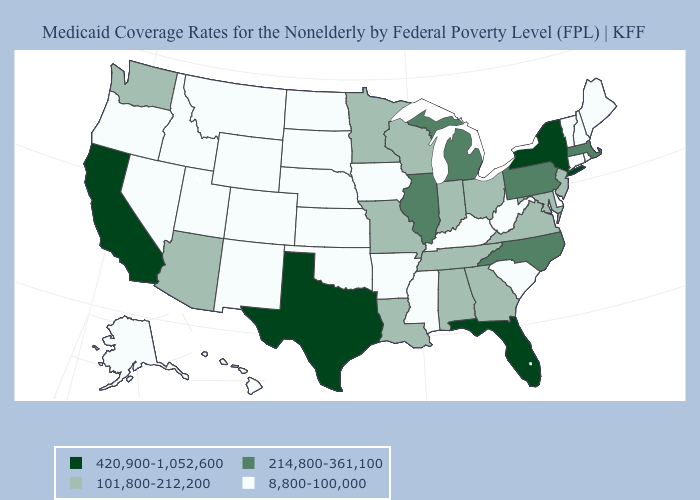How many symbols are there in the legend?
Short answer required. 4. What is the value of California?
Give a very brief answer. 420,900-1,052,600. What is the lowest value in the USA?
Write a very short answer. 8,800-100,000. What is the lowest value in states that border Massachusetts?
Concise answer only. 8,800-100,000. Among the states that border Iowa , does Nebraska have the lowest value?
Short answer required. Yes. What is the value of Rhode Island?
Write a very short answer. 8,800-100,000. Name the states that have a value in the range 420,900-1,052,600?
Concise answer only. California, Florida, New York, Texas. Does North Dakota have the lowest value in the MidWest?
Write a very short answer. Yes. What is the value of Rhode Island?
Keep it brief. 8,800-100,000. What is the value of Montana?
Quick response, please. 8,800-100,000. What is the value of Arizona?
Write a very short answer. 101,800-212,200. Name the states that have a value in the range 214,800-361,100?
Give a very brief answer. Illinois, Massachusetts, Michigan, North Carolina, Pennsylvania. Does the first symbol in the legend represent the smallest category?
Concise answer only. No. What is the value of Virginia?
Quick response, please. 101,800-212,200. What is the value of Texas?
Be succinct. 420,900-1,052,600. 